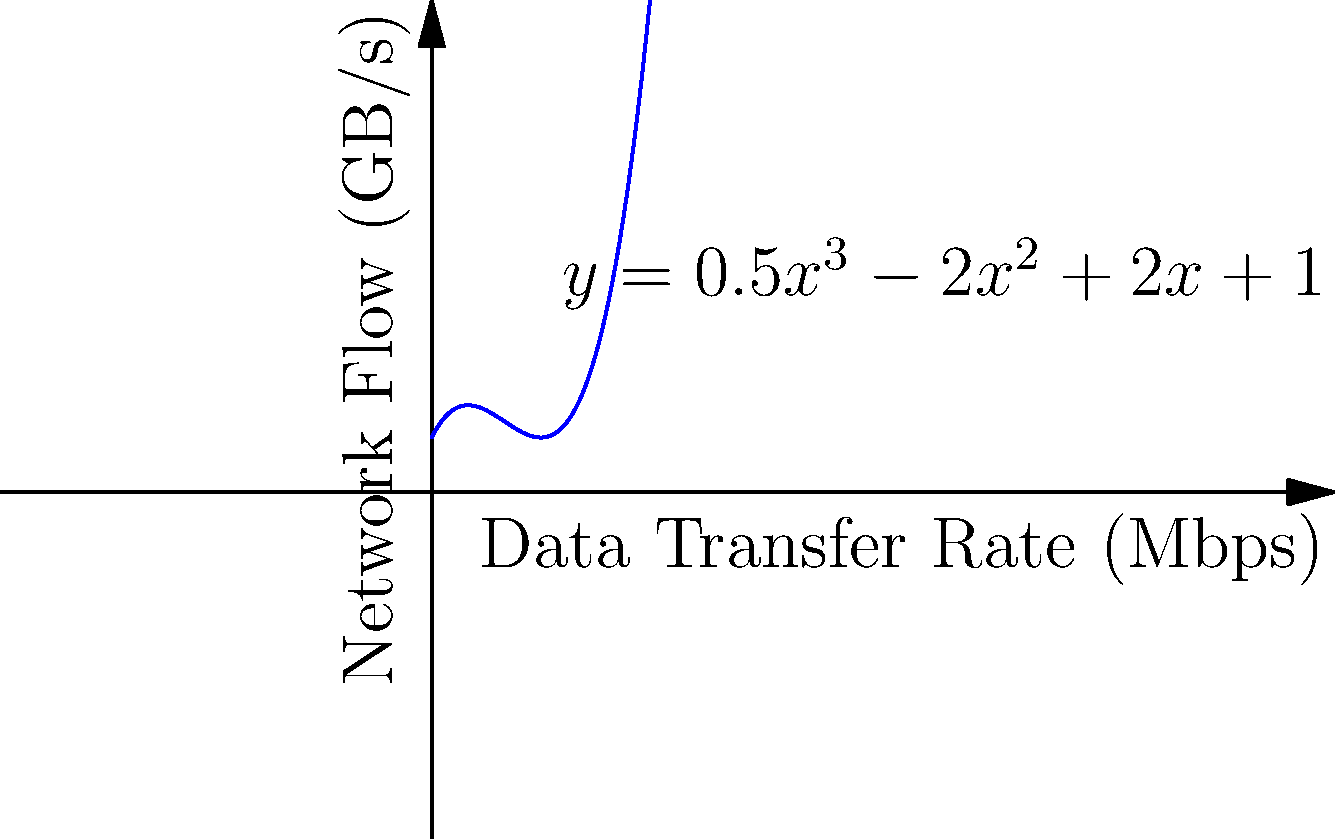Given the polynomial function $f(x) = 0.5x^3 - 2x^2 + 2x + 1$ modeling the relationship between data transfer rate (x, in Mbps) and network flow (y, in GB/s), at what data transfer rate does the network flow reach its local minimum? Round your answer to two decimal places. To find the local minimum of the network flow, we need to follow these steps:

1) The local minimum occurs at a point where the derivative of the function is zero. So, we need to find $f'(x)$ and set it to zero.

2) $f'(x) = 1.5x^2 - 4x + 2$

3) Set $f'(x) = 0$:
   $1.5x^2 - 4x + 2 = 0$

4) This is a quadratic equation. We can solve it using the quadratic formula:
   $x = \frac{-b \pm \sqrt{b^2 - 4ac}}{2a}$

   Where $a = 1.5$, $b = -4$, and $c = 2$

5) Plugging in these values:
   $x = \frac{4 \pm \sqrt{16 - 12}}{3} = \frac{4 \pm \sqrt{4}}{3} = \frac{4 \pm 2}{3}$

6) This gives us two solutions:
   $x_1 = \frac{4 + 2}{3} = 2$
   $x_2 = \frac{4 - 2}{3} = \frac{2}{3} \approx 0.67$

7) To determine which of these is the minimum (rather than the maximum), we can check the second derivative:
   $f''(x) = 3x - 4$

8) At $x = 2$, $f''(2) = 2 > 0$, indicating a local minimum.
   At $x = \frac{2}{3}$, $f''(\frac{2}{3}) = -2 < 0$, indicating a local maximum.

Therefore, the local minimum occurs at $x = 2$.
Answer: 2.00 Mbps 